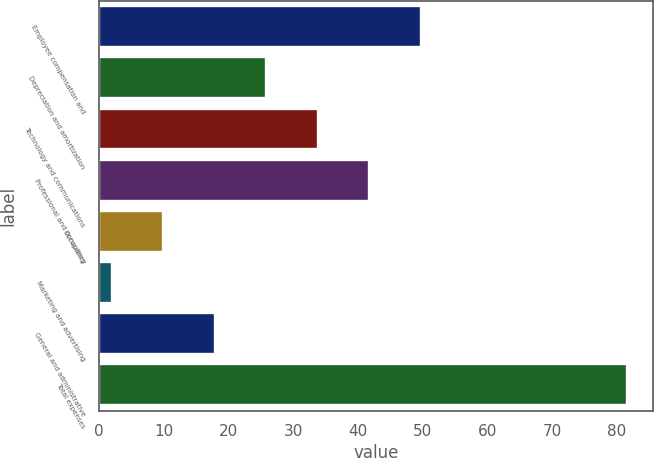Convert chart. <chart><loc_0><loc_0><loc_500><loc_500><bar_chart><fcel>Employee compensation and<fcel>Depreciation and amortization<fcel>Technology and communications<fcel>Professional and consulting<fcel>Occupancy<fcel>Marketing and advertising<fcel>General and administrative<fcel>Total expenses<nl><fcel>49.76<fcel>25.88<fcel>33.84<fcel>41.8<fcel>9.96<fcel>2<fcel>17.92<fcel>81.6<nl></chart> 